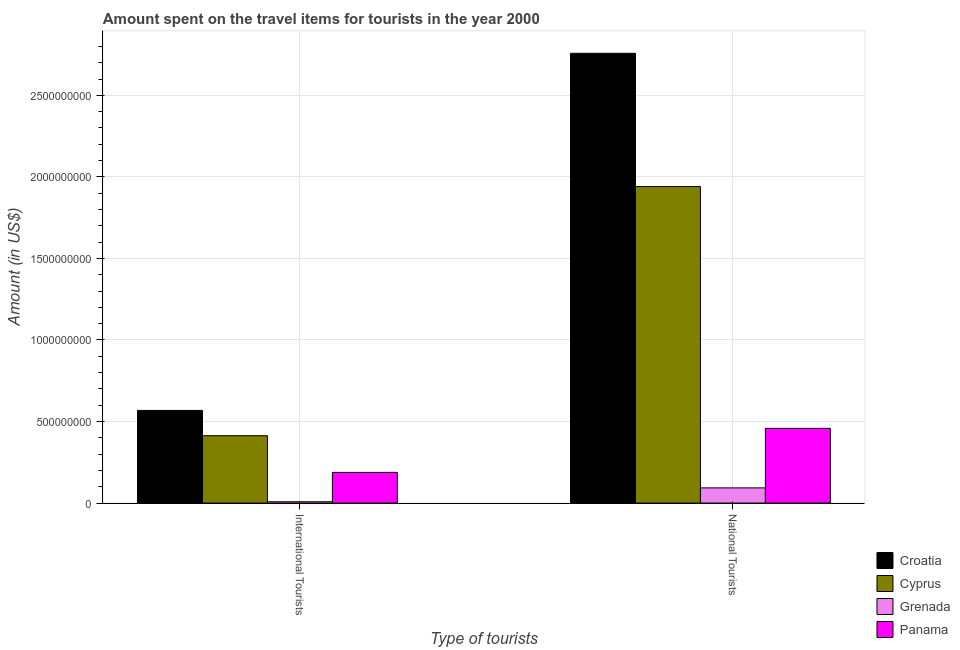How many different coloured bars are there?
Ensure brevity in your answer.  4. How many bars are there on the 1st tick from the right?
Offer a very short reply. 4. What is the label of the 1st group of bars from the left?
Ensure brevity in your answer.  International Tourists. What is the amount spent on travel items of national tourists in Croatia?
Provide a succinct answer. 2.76e+09. Across all countries, what is the maximum amount spent on travel items of international tourists?
Your answer should be very brief. 5.68e+08. Across all countries, what is the minimum amount spent on travel items of national tourists?
Give a very brief answer. 9.30e+07. In which country was the amount spent on travel items of international tourists maximum?
Ensure brevity in your answer.  Croatia. In which country was the amount spent on travel items of international tourists minimum?
Ensure brevity in your answer.  Grenada. What is the total amount spent on travel items of international tourists in the graph?
Your answer should be very brief. 1.18e+09. What is the difference between the amount spent on travel items of international tourists in Cyprus and that in Panama?
Offer a terse response. 2.25e+08. What is the difference between the amount spent on travel items of national tourists in Grenada and the amount spent on travel items of international tourists in Cyprus?
Provide a succinct answer. -3.20e+08. What is the average amount spent on travel items of international tourists per country?
Make the answer very short. 2.94e+08. What is the difference between the amount spent on travel items of international tourists and amount spent on travel items of national tourists in Cyprus?
Make the answer very short. -1.53e+09. What is the ratio of the amount spent on travel items of international tourists in Cyprus to that in Croatia?
Provide a short and direct response. 0.73. What does the 3rd bar from the left in National Tourists represents?
Your response must be concise. Grenada. What does the 2nd bar from the right in National Tourists represents?
Your answer should be compact. Grenada. Are the values on the major ticks of Y-axis written in scientific E-notation?
Offer a terse response. No. Where does the legend appear in the graph?
Your answer should be very brief. Bottom right. What is the title of the graph?
Your response must be concise. Amount spent on the travel items for tourists in the year 2000. What is the label or title of the X-axis?
Ensure brevity in your answer.  Type of tourists. What is the Amount (in US$) in Croatia in International Tourists?
Make the answer very short. 5.68e+08. What is the Amount (in US$) in Cyprus in International Tourists?
Make the answer very short. 4.13e+08. What is the Amount (in US$) of Panama in International Tourists?
Give a very brief answer. 1.88e+08. What is the Amount (in US$) in Croatia in National Tourists?
Provide a succinct answer. 2.76e+09. What is the Amount (in US$) of Cyprus in National Tourists?
Provide a short and direct response. 1.94e+09. What is the Amount (in US$) of Grenada in National Tourists?
Give a very brief answer. 9.30e+07. What is the Amount (in US$) of Panama in National Tourists?
Your answer should be compact. 4.58e+08. Across all Type of tourists, what is the maximum Amount (in US$) in Croatia?
Offer a terse response. 2.76e+09. Across all Type of tourists, what is the maximum Amount (in US$) of Cyprus?
Your answer should be very brief. 1.94e+09. Across all Type of tourists, what is the maximum Amount (in US$) of Grenada?
Ensure brevity in your answer.  9.30e+07. Across all Type of tourists, what is the maximum Amount (in US$) in Panama?
Your answer should be compact. 4.58e+08. Across all Type of tourists, what is the minimum Amount (in US$) of Croatia?
Your answer should be very brief. 5.68e+08. Across all Type of tourists, what is the minimum Amount (in US$) of Cyprus?
Ensure brevity in your answer.  4.13e+08. Across all Type of tourists, what is the minimum Amount (in US$) of Panama?
Ensure brevity in your answer.  1.88e+08. What is the total Amount (in US$) in Croatia in the graph?
Your response must be concise. 3.33e+09. What is the total Amount (in US$) of Cyprus in the graph?
Keep it short and to the point. 2.35e+09. What is the total Amount (in US$) of Grenada in the graph?
Offer a terse response. 1.01e+08. What is the total Amount (in US$) of Panama in the graph?
Ensure brevity in your answer.  6.46e+08. What is the difference between the Amount (in US$) of Croatia in International Tourists and that in National Tourists?
Your answer should be very brief. -2.19e+09. What is the difference between the Amount (in US$) in Cyprus in International Tourists and that in National Tourists?
Offer a terse response. -1.53e+09. What is the difference between the Amount (in US$) in Grenada in International Tourists and that in National Tourists?
Your answer should be compact. -8.50e+07. What is the difference between the Amount (in US$) in Panama in International Tourists and that in National Tourists?
Make the answer very short. -2.70e+08. What is the difference between the Amount (in US$) of Croatia in International Tourists and the Amount (in US$) of Cyprus in National Tourists?
Your response must be concise. -1.37e+09. What is the difference between the Amount (in US$) of Croatia in International Tourists and the Amount (in US$) of Grenada in National Tourists?
Keep it short and to the point. 4.75e+08. What is the difference between the Amount (in US$) in Croatia in International Tourists and the Amount (in US$) in Panama in National Tourists?
Offer a terse response. 1.10e+08. What is the difference between the Amount (in US$) in Cyprus in International Tourists and the Amount (in US$) in Grenada in National Tourists?
Offer a very short reply. 3.20e+08. What is the difference between the Amount (in US$) in Cyprus in International Tourists and the Amount (in US$) in Panama in National Tourists?
Offer a very short reply. -4.50e+07. What is the difference between the Amount (in US$) in Grenada in International Tourists and the Amount (in US$) in Panama in National Tourists?
Keep it short and to the point. -4.50e+08. What is the average Amount (in US$) of Croatia per Type of tourists?
Your answer should be very brief. 1.66e+09. What is the average Amount (in US$) in Cyprus per Type of tourists?
Provide a succinct answer. 1.18e+09. What is the average Amount (in US$) of Grenada per Type of tourists?
Give a very brief answer. 5.05e+07. What is the average Amount (in US$) in Panama per Type of tourists?
Ensure brevity in your answer.  3.23e+08. What is the difference between the Amount (in US$) in Croatia and Amount (in US$) in Cyprus in International Tourists?
Ensure brevity in your answer.  1.55e+08. What is the difference between the Amount (in US$) of Croatia and Amount (in US$) of Grenada in International Tourists?
Offer a terse response. 5.60e+08. What is the difference between the Amount (in US$) of Croatia and Amount (in US$) of Panama in International Tourists?
Give a very brief answer. 3.80e+08. What is the difference between the Amount (in US$) of Cyprus and Amount (in US$) of Grenada in International Tourists?
Keep it short and to the point. 4.05e+08. What is the difference between the Amount (in US$) of Cyprus and Amount (in US$) of Panama in International Tourists?
Ensure brevity in your answer.  2.25e+08. What is the difference between the Amount (in US$) in Grenada and Amount (in US$) in Panama in International Tourists?
Give a very brief answer. -1.80e+08. What is the difference between the Amount (in US$) of Croatia and Amount (in US$) of Cyprus in National Tourists?
Ensure brevity in your answer.  8.17e+08. What is the difference between the Amount (in US$) of Croatia and Amount (in US$) of Grenada in National Tourists?
Your response must be concise. 2.66e+09. What is the difference between the Amount (in US$) of Croatia and Amount (in US$) of Panama in National Tourists?
Make the answer very short. 2.30e+09. What is the difference between the Amount (in US$) of Cyprus and Amount (in US$) of Grenada in National Tourists?
Your response must be concise. 1.85e+09. What is the difference between the Amount (in US$) of Cyprus and Amount (in US$) of Panama in National Tourists?
Your answer should be very brief. 1.48e+09. What is the difference between the Amount (in US$) in Grenada and Amount (in US$) in Panama in National Tourists?
Keep it short and to the point. -3.65e+08. What is the ratio of the Amount (in US$) in Croatia in International Tourists to that in National Tourists?
Ensure brevity in your answer.  0.21. What is the ratio of the Amount (in US$) of Cyprus in International Tourists to that in National Tourists?
Provide a short and direct response. 0.21. What is the ratio of the Amount (in US$) of Grenada in International Tourists to that in National Tourists?
Your answer should be compact. 0.09. What is the ratio of the Amount (in US$) in Panama in International Tourists to that in National Tourists?
Provide a short and direct response. 0.41. What is the difference between the highest and the second highest Amount (in US$) of Croatia?
Ensure brevity in your answer.  2.19e+09. What is the difference between the highest and the second highest Amount (in US$) of Cyprus?
Provide a succinct answer. 1.53e+09. What is the difference between the highest and the second highest Amount (in US$) of Grenada?
Offer a terse response. 8.50e+07. What is the difference between the highest and the second highest Amount (in US$) in Panama?
Give a very brief answer. 2.70e+08. What is the difference between the highest and the lowest Amount (in US$) in Croatia?
Offer a very short reply. 2.19e+09. What is the difference between the highest and the lowest Amount (in US$) in Cyprus?
Give a very brief answer. 1.53e+09. What is the difference between the highest and the lowest Amount (in US$) in Grenada?
Provide a succinct answer. 8.50e+07. What is the difference between the highest and the lowest Amount (in US$) in Panama?
Your answer should be very brief. 2.70e+08. 